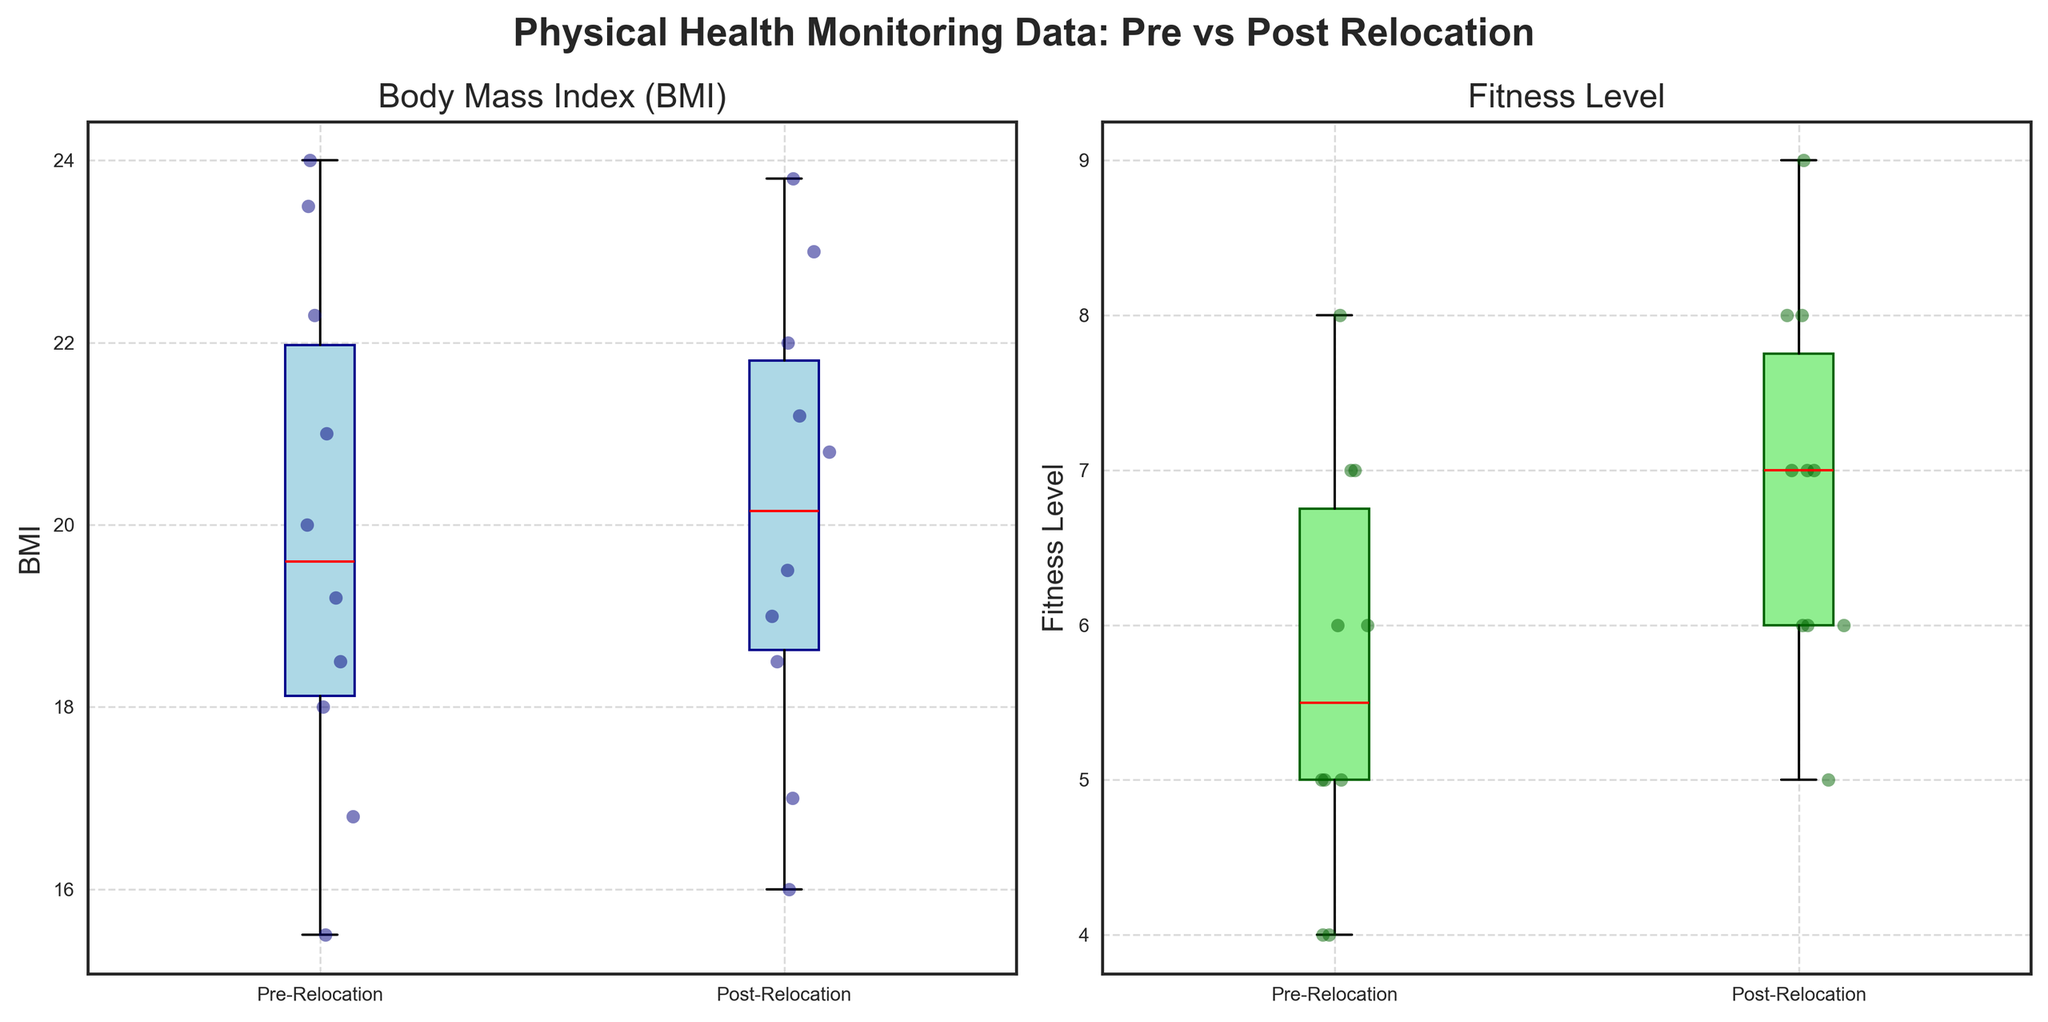What's the title of the figure? The title of the figure is usually displayed at the top of the plot, indicating the overall content. The title in the figure reads "Physical Health Monitoring Data: Pre vs Post Relocation".
Answer: Physical Health Monitoring Data: Pre vs Post Relocation How many periods are compared in the figure? The figure compares two periods as indicated by the x-axis labels: "Pre-Relocation" and "Post-Relocation".
Answer: 2 What is the median BMI value for the pre-relocation period? The median BMI value can be identified by the location of the red line within the blue box plot under the "Pre-Relocation" label on the BMI subplot.
Answer: approximately 21.0 What’s the range of Fitness Levels in the post-relocation period? The range of Fitness Levels can be identified by the vertical extent of the green box plot under the "Post-Relocation" label on the Fitness Level subplot.
Answer: 5 to 9 Which period shows higher variability in BMI values? Variability in BMI values can be identified by comparing the interquartile ranges (IQR), represented by the heights of the blue boxes. Higher IQR indicates higher variability.
Answer: Pre-Relocation What’s the change in median Fitness Levels from pre-relocation to post-relocation? The change can be determined by comparing the medians (red lines) in both periods within the Fitness Level subplot. The median for the pre-relocation period is around 6, and the post-relocation median is about 7.
Answer: Increased by 1 How does the median BMI value compare between pre-relocation and post-relocation periods? To compare, look at the red lines in the blue box plots for both periods within the BMI subplot. The median value suggests that post-relocation BMI is slightly higher.
Answer: Post-relocation is slightly higher Which subplot uses light green color for the box? The subplot titles can help identify the specific plots. The box plot for Fitness Level uses light green color for the boxes.
Answer: Fitness Level Is there an outlier in the post-relocation BMI data? Outliers can typically be identified by looking for individual points outside the whiskers of the box plot. In this case, there is no point outside the whiskers in the post-relocation BMI data.
Answer: No How does the range of BMI values compare between the pre-relocation and post-relocation periods? The range can be identified by the whiskers' lengths. Compare the lengths of the whiskers in the blue box plots for both periods in the BMI subplot.
Answer: Pre-relocation has a wider range 